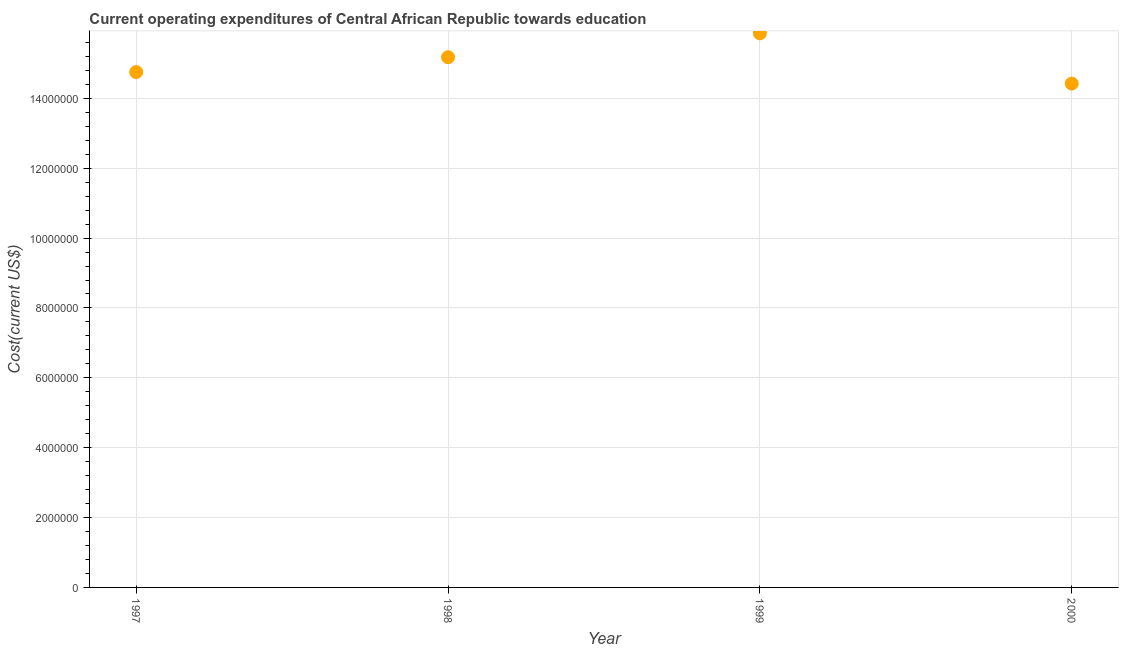What is the education expenditure in 2000?
Your answer should be very brief. 1.44e+07. Across all years, what is the maximum education expenditure?
Keep it short and to the point. 1.59e+07. Across all years, what is the minimum education expenditure?
Give a very brief answer. 1.44e+07. In which year was the education expenditure maximum?
Provide a short and direct response. 1999. In which year was the education expenditure minimum?
Provide a short and direct response. 2000. What is the sum of the education expenditure?
Offer a very short reply. 6.02e+07. What is the difference between the education expenditure in 1997 and 2000?
Keep it short and to the point. 3.29e+05. What is the average education expenditure per year?
Your response must be concise. 1.51e+07. What is the median education expenditure?
Offer a very short reply. 1.50e+07. In how many years, is the education expenditure greater than 800000 US$?
Your response must be concise. 4. What is the ratio of the education expenditure in 1997 to that in 1998?
Ensure brevity in your answer.  0.97. Is the education expenditure in 1997 less than that in 1999?
Make the answer very short. Yes. What is the difference between the highest and the second highest education expenditure?
Provide a succinct answer. 6.84e+05. Is the sum of the education expenditure in 1999 and 2000 greater than the maximum education expenditure across all years?
Your answer should be compact. Yes. What is the difference between the highest and the lowest education expenditure?
Provide a short and direct response. 1.44e+06. In how many years, is the education expenditure greater than the average education expenditure taken over all years?
Make the answer very short. 2. Does the education expenditure monotonically increase over the years?
Offer a terse response. No. How many dotlines are there?
Your answer should be compact. 1. How many years are there in the graph?
Your response must be concise. 4. Does the graph contain any zero values?
Ensure brevity in your answer.  No. What is the title of the graph?
Offer a very short reply. Current operating expenditures of Central African Republic towards education. What is the label or title of the Y-axis?
Provide a short and direct response. Cost(current US$). What is the Cost(current US$) in 1997?
Your answer should be very brief. 1.48e+07. What is the Cost(current US$) in 1998?
Your answer should be compact. 1.52e+07. What is the Cost(current US$) in 1999?
Provide a short and direct response. 1.59e+07. What is the Cost(current US$) in 2000?
Provide a succinct answer. 1.44e+07. What is the difference between the Cost(current US$) in 1997 and 1998?
Offer a very short reply. -4.26e+05. What is the difference between the Cost(current US$) in 1997 and 1999?
Provide a succinct answer. -1.11e+06. What is the difference between the Cost(current US$) in 1997 and 2000?
Your answer should be compact. 3.29e+05. What is the difference between the Cost(current US$) in 1998 and 1999?
Offer a very short reply. -6.84e+05. What is the difference between the Cost(current US$) in 1998 and 2000?
Give a very brief answer. 7.55e+05. What is the difference between the Cost(current US$) in 1999 and 2000?
Your answer should be compact. 1.44e+06. What is the ratio of the Cost(current US$) in 1997 to that in 1999?
Offer a very short reply. 0.93. What is the ratio of the Cost(current US$) in 1997 to that in 2000?
Give a very brief answer. 1.02. What is the ratio of the Cost(current US$) in 1998 to that in 1999?
Your response must be concise. 0.96. What is the ratio of the Cost(current US$) in 1998 to that in 2000?
Ensure brevity in your answer.  1.05. What is the ratio of the Cost(current US$) in 1999 to that in 2000?
Offer a very short reply. 1.1. 